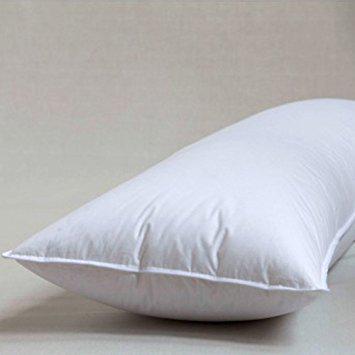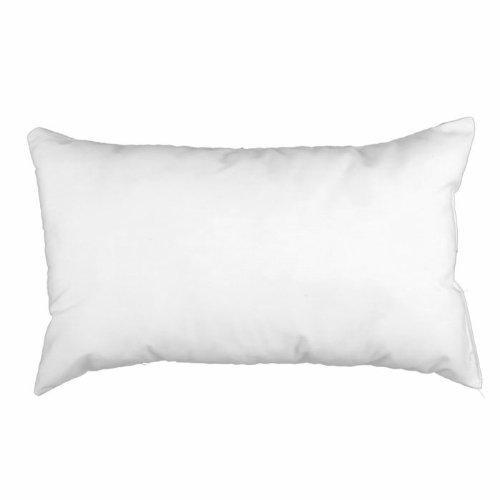The first image is the image on the left, the second image is the image on the right. Examine the images to the left and right. Is the description "The pillow on the right is white and displayed horizontally, and the pillow on the left is white and displayed at some angle instead of horizontally." accurate? Answer yes or no. Yes. 